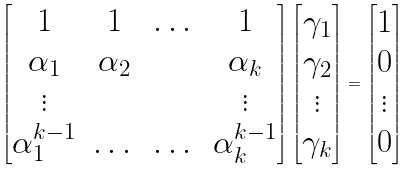<formula> <loc_0><loc_0><loc_500><loc_500>\left [ \begin{matrix} 1 & 1 & \dots & 1 \\ \alpha _ { 1 } & \alpha _ { 2 } & & \alpha _ { k } \\ \vdots & & & \vdots \\ \alpha ^ { k - 1 } _ { 1 } & \dots & \dots & \alpha ^ { k - 1 } _ { k } \end{matrix} \right ] \left [ \begin{matrix} \gamma _ { 1 } \\ \gamma _ { 2 } \\ \vdots \\ \gamma _ { k } \end{matrix} \right ] = \left [ \begin{matrix} 1 \\ 0 \\ \vdots \\ 0 \end{matrix} \right ]</formula> 